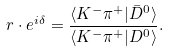Convert formula to latex. <formula><loc_0><loc_0><loc_500><loc_500>r \cdot e ^ { i \delta } = \frac { \langle K ^ { - } \pi ^ { + } | \bar { D } ^ { 0 } \rangle } { \langle K ^ { - } \pi ^ { + } | D ^ { 0 } \rangle } .</formula> 